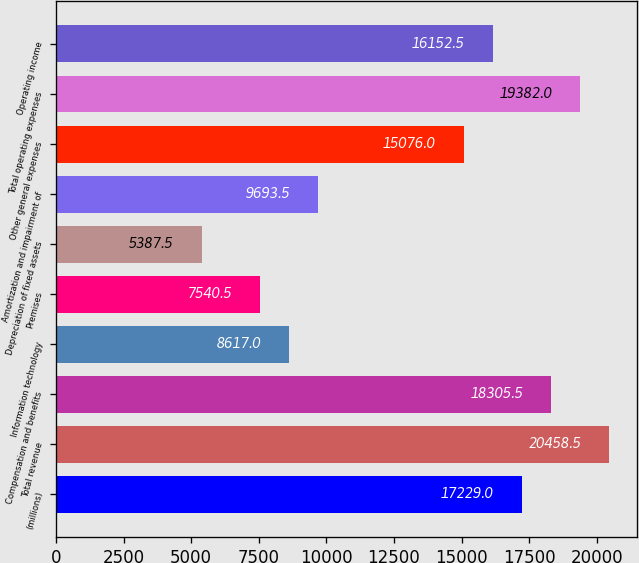Convert chart. <chart><loc_0><loc_0><loc_500><loc_500><bar_chart><fcel>(millions)<fcel>Total revenue<fcel>Compensation and benefits<fcel>Information technology<fcel>Premises<fcel>Depreciation of fixed assets<fcel>Amortization and impairment of<fcel>Other general expenses<fcel>Total operating expenses<fcel>Operating income<nl><fcel>17229<fcel>20458.5<fcel>18305.5<fcel>8617<fcel>7540.5<fcel>5387.5<fcel>9693.5<fcel>15076<fcel>19382<fcel>16152.5<nl></chart> 